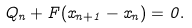Convert formula to latex. <formula><loc_0><loc_0><loc_500><loc_500>Q _ { n } + F ( x _ { n + 1 } - x _ { n } ) = 0 .</formula> 